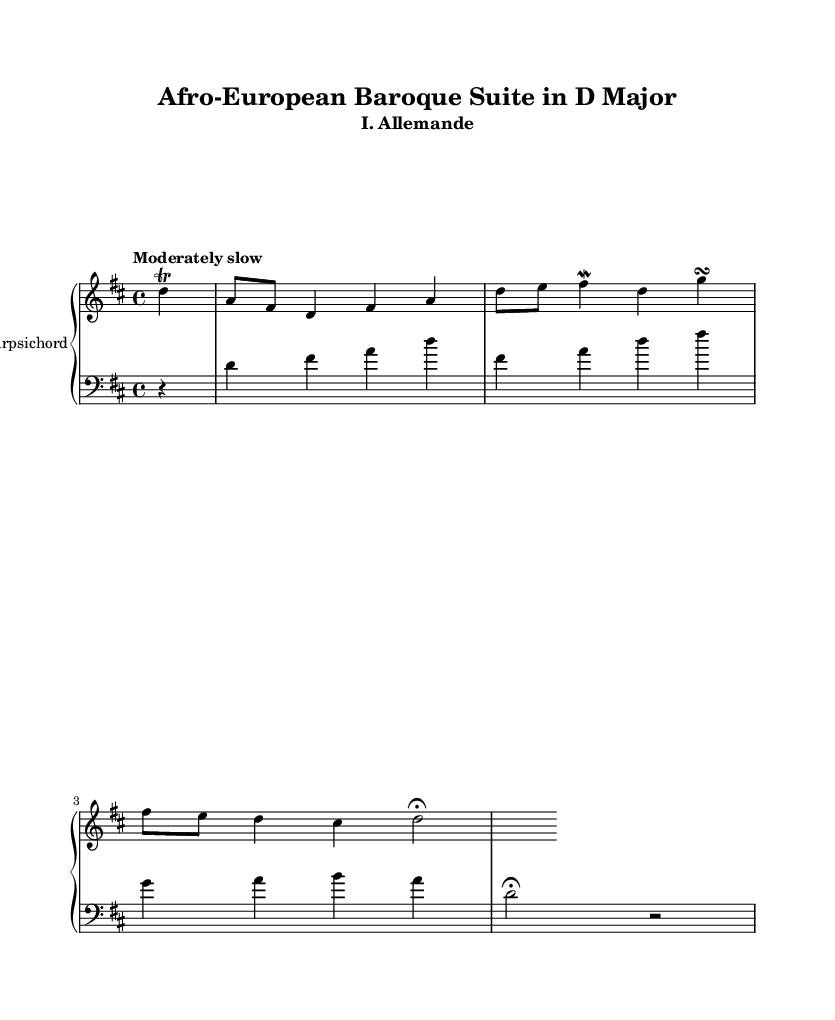What is the key signature of this music? The key signature is D major, which has two sharps (F# and C#). This can be identified by looking at the clef and the sharps indicated at the beginning of the staff.
Answer: D major What is the time signature of this piece? The time signature is 4/4, meaning there are four beats in each measure. This is clearly indicated at the beginning of the piece, right underneath the key signature.
Answer: 4/4 What is the tempo marking for this music? The tempo marking is "Moderately slow," which is specified at the beginning of the score. This indicates the intended speed at which the piece should be played.
Answer: Moderately slow How many measures are there in the right hand part? There are 10 measures in the right hand part. By counting each measure marked in the right-hand staff, we can arrive at this total.
Answer: 10 Which ornament appears at least once in the right hand? A trill appears at least once in the right hand, as indicated by the "trill" marking placed over the note. This ornament is characteristic of Baroque music, emphasizing the embellishment typical of that style.
Answer: trill What is the last note in the left hand part? The last note in the left hand part is a fermata on D, indicating that it should be held longer than its usual duration. This is noted at the end of the left hand staff.
Answer: D What characterizes the form of this suite as a Baroque piece? The suite is characterized by the presence of dance movements, like the Allemande, which is typical in baroque suites. This is seen in the title indicating it as the first movement of a suite, adhering to genres common in the Baroque era.
Answer: dance movements 